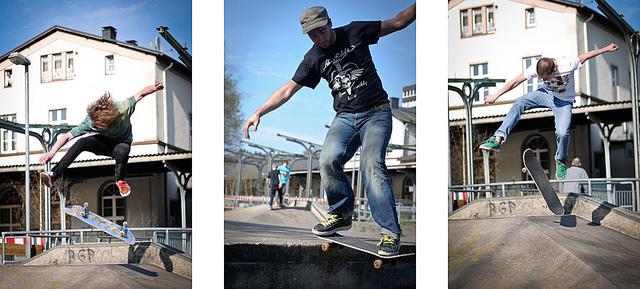What activity is being performed?
Concise answer only. Skateboarding. Is it cloudy?
Answer briefly. No. Which picture was taken in a different spot?
Keep it brief. Middle. 